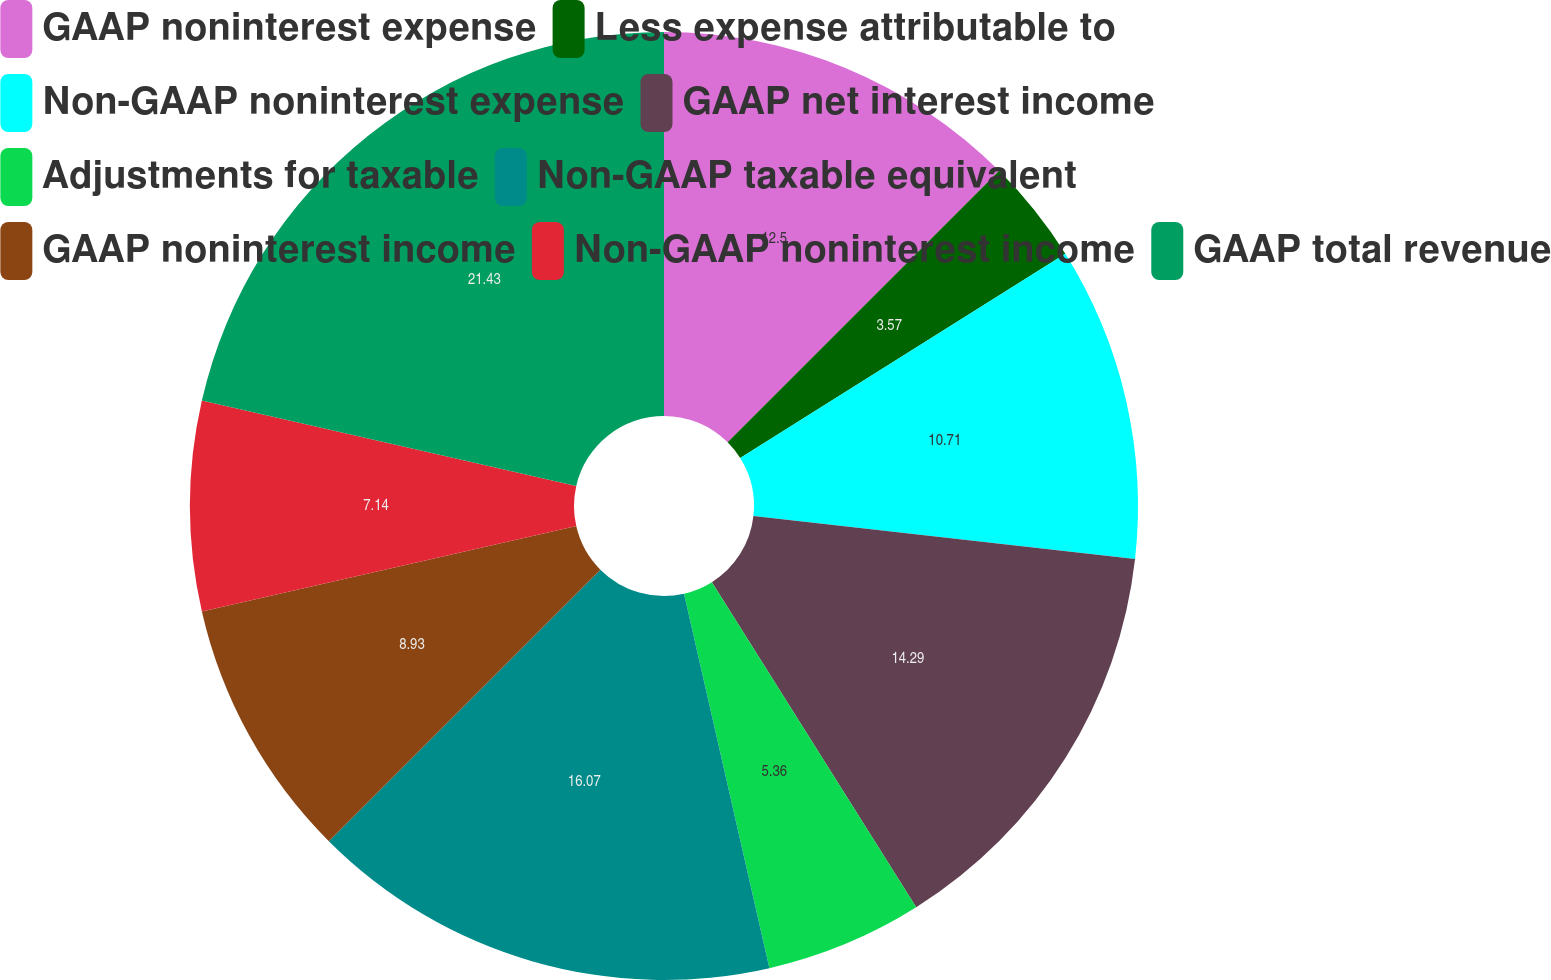Convert chart to OTSL. <chart><loc_0><loc_0><loc_500><loc_500><pie_chart><fcel>GAAP noninterest expense<fcel>Less expense attributable to<fcel>Non-GAAP noninterest expense<fcel>GAAP net interest income<fcel>Adjustments for taxable<fcel>Non-GAAP taxable equivalent<fcel>GAAP noninterest income<fcel>Non-GAAP noninterest income<fcel>GAAP total revenue<nl><fcel>12.5%<fcel>3.57%<fcel>10.71%<fcel>14.29%<fcel>5.36%<fcel>16.07%<fcel>8.93%<fcel>7.14%<fcel>21.43%<nl></chart> 